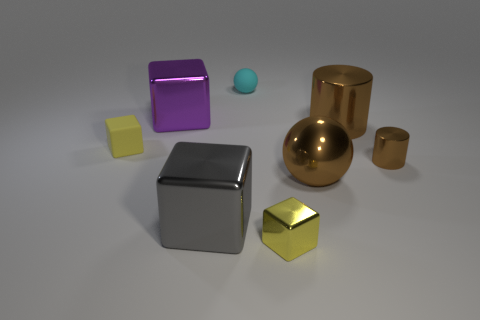Subtract all yellow balls. How many yellow blocks are left? 2 Subtract all gray shiny blocks. How many blocks are left? 3 Subtract all purple blocks. How many blocks are left? 3 Subtract 1 blocks. How many blocks are left? 3 Add 1 small yellow objects. How many objects exist? 9 Subtract all brown blocks. Subtract all purple balls. How many blocks are left? 4 Subtract all big purple blocks. Subtract all small brown cylinders. How many objects are left? 6 Add 4 matte objects. How many matte objects are left? 6 Add 6 gray cubes. How many gray cubes exist? 7 Subtract 0 purple spheres. How many objects are left? 8 